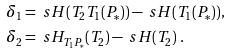<formula> <loc_0><loc_0><loc_500><loc_500>& \delta _ { 1 } = \ s H ( T _ { 2 } T _ { 1 } ( P _ { * } ) ) - \ s H ( T _ { 1 } ( P _ { * } ) ) , \\ & \delta _ { 2 } = \ s H _ { T _ { 1 } P _ { * } } ( T _ { 2 } ) - \ s H ( T _ { 2 } ) \ .</formula> 